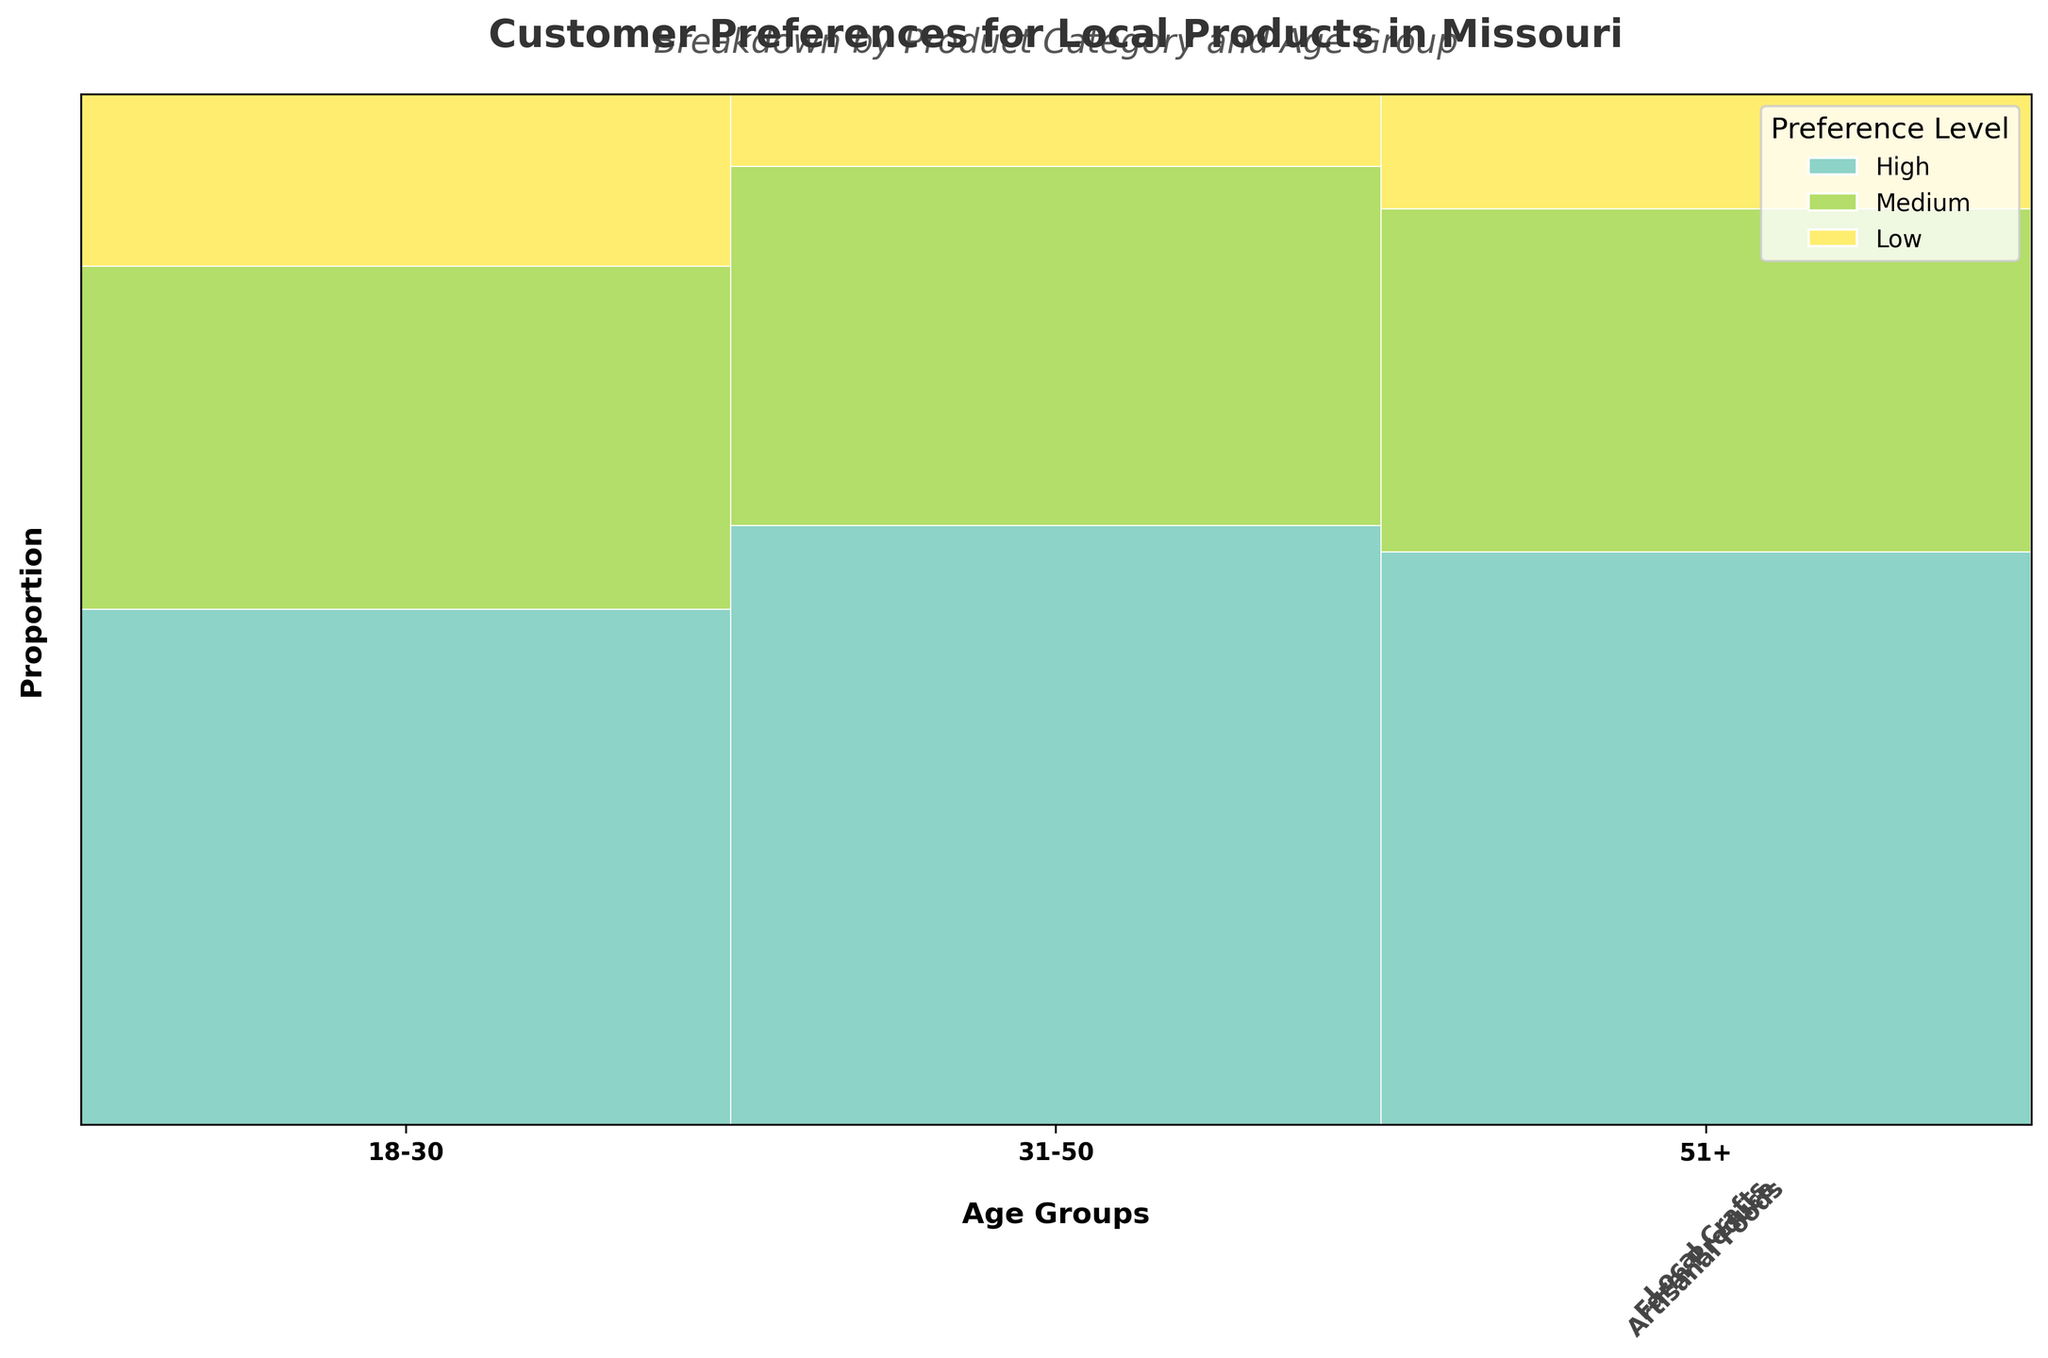What is the title of the plot? The title is prominently displayed at the top center of the plot. It reads "Customer Preferences for Local Products in Missouri."
Answer: Customer Preferences for Local Products in Missouri Which age group shows the highest proportion of high preference for Farm Produce? To determine this, look at the segments representing high preference for Farm Produce in each age group (they are the tallest segments within the Farm Produce category). The age group 31-50 has the highest proportion of high preference.
Answer: 31-50 How does the preference for Artisanal Foods compare between the 18-30 and 51+ age groups? Compare the heights of the high, medium, and low preference segments for Artisanal Foods between the 18-30 and 51+ age groups. The 51+ age group shows a higher proportion of high preference and medium preference, while the 18-30 age group has a higher proportion of low preference.
Answer: The 51+ age group prefers Artisanal Foods more than the 18-30 age group Which product category has the most even distribution of preferences across all age groups? Examine the relative heights of the high, medium, and low preference segments within each product category. Local Crafts show the most even distribution, as the preference segments are more balanced compared to Artisanal Foods and Farm Produce.
Answer: Local Crafts Among the 31-50 age group, which product category has the least low preference? For the 31-50 age group, compare the heights of the low preference segments for each product category. Farm Produce has the smallest segment representing low preference, indicating it has the least low preference.
Answer: Farm Produce In the 18-30 age group, which product category has the highest medium preference? Look at the medium preference segments in the 18-30 age group for each product category. Artisanal Foods has the highest medium preference proportion compared to Local Crafts and Farm Produce.
Answer: Artisanal Foods Which age group shows the highest total preference for Local Crafts (considering high, medium, and low preferences)? Sum the heights of the high, medium, and low preference segments for Local Crafts in each age group. The 51+ age group has the highest total proportion of preferences for Local Crafts.
Answer: 51+ Explain the preference trend for Farm Produce as age increases. Analyze the segments representing high, medium, and low preferences for Farm Produce across the three age groups. The proportion of high preference increases from the 18-30 age group to the 31-50 age group and then slightly decreases in the 51+ age group. Meanwhile, medium and low preferences decrease as age increases.
Answer: High preference increases then slightly decreases, while medium and low preferences decrease as age increases Overall, which age group has the strongest preference for local products, considering high preference across all categories? Summing up the high preference proportions across all product categories for each age group, the 31-50 age group consistently shows the highest high preference proportions, followed by the 51+ age group, and then the 18-30 age group.
Answer: 31-50 